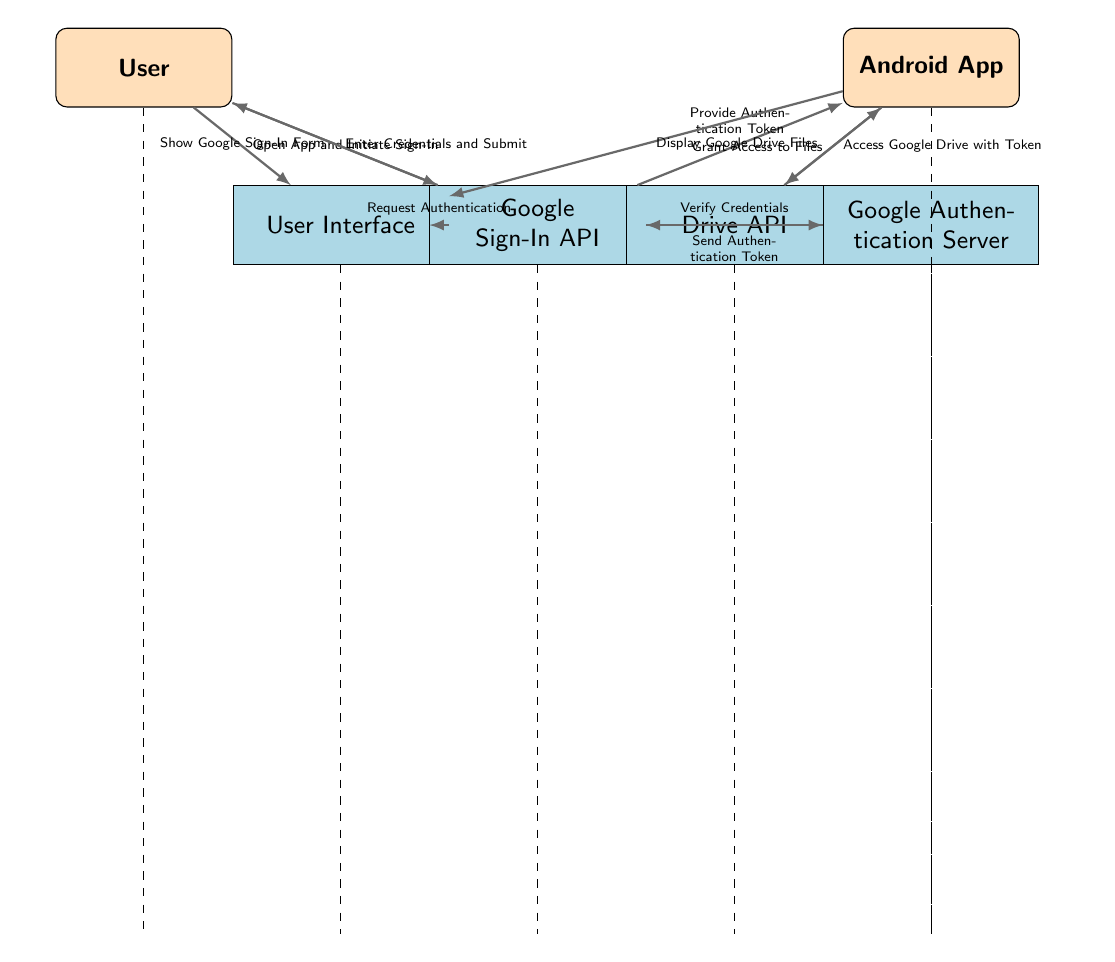What is the first action taken by the user? The diagram shows that the first action taken by the user is to open the app and initiate sign-in. This is represented by the arrow connecting the User node to the User Interface node, with the label indicating this action.
Answer: Open App and Initiate Sign-In What components are involved in the authentication process? The diagram includes several components involved in the authentication process: User, Android App, User Interface, Google Sign-In API, Drive API, and Google Authentication Server. By listing all nodes present, we identify these components.
Answer: User, Android App, User Interface, Google Sign-In API, Drive API, Google Authentication Server How many main nodes are present in the diagram? The main nodes in the diagram are User, Android App, User Interface, Google Sign-In API, Drive API, and Google Authentication Server, totaling six nodes. Counting each node helps determine the total number present.
Answer: 6 What does the Google Sign-In API show to the user? According to the diagram, the Google Sign-In API shows the Google Sign-In Form to the user. This is indicated by the arrow going from the Google Sign-In API to the User, labeled appropriately.
Answer: Show Google Sign-In Form Which node is responsible for verifying credentials? The diagram indicates that the Google Authentication Server is responsible for verifying credentials. This is demonstrated by the interaction where the Google Sign-In API sends a request to the Google Authentication Server to verify credentials.
Answer: Google Authentication Server What is sent back to the Google Sign-In API from the Google Authentication Server? The Google Authentication Server sends back an authentication token to the Google Sign-In API. This is represented by the arrow moving from the Google Authentication Server to the Google Sign-In API that is labeled “Send Authentication Token.”
Answer: Send Authentication Token What action does the Android App take after receiving an authentication token? After receiving the authentication token, the Android App accesses Google Drive with this token. This sequence is outlined by the arrow connecting the Android App to the Drive API, indicating the action taken.
Answer: Access Google Drive with Token What is the final outcome displayed to the user within the app? The final outcome displayed to the user within the app is the Google Drive files, as shown by the arrow connecting the Android App back to the User Interface with the label stating "Display Google Drive Files."
Answer: Display Google Drive Files 